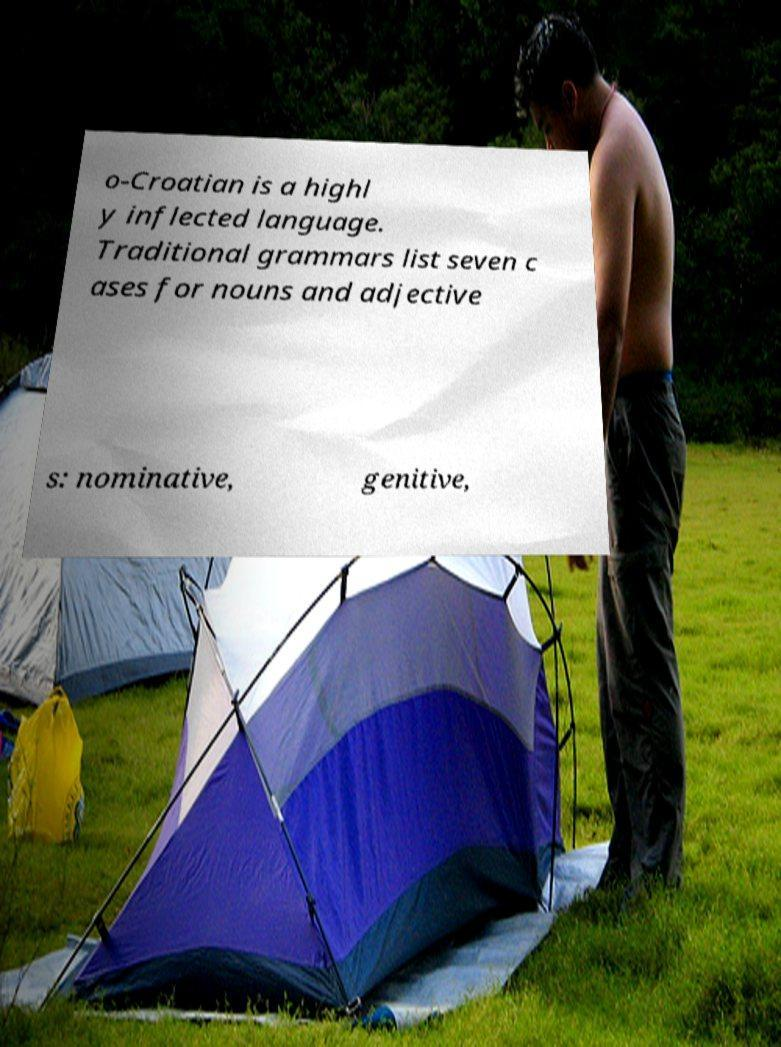Please identify and transcribe the text found in this image. o-Croatian is a highl y inflected language. Traditional grammars list seven c ases for nouns and adjective s: nominative, genitive, 